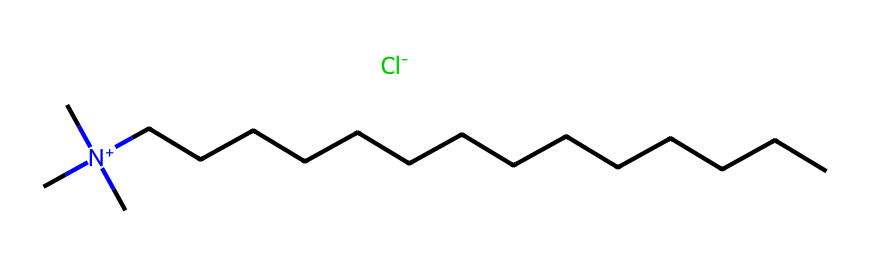What is the molecular cation in this compound? The compound has a positively charged nitrogen atom ([N+]), which is surrounded by three carbon groups (C) and a long hydrocarbon chain (CCCCCCCCCCCCCC). This indicates the presence of a quaternary ammonium ion.
Answer: quaternary ammonium ion How many carbon atoms are present in the long hydrocarbon chain? The long hydrocarbon chain is indicated by the series of carbon atoms labeled as CCCCCCCCCCCCCC, which has 14 carbon atoms.
Answer: 14 What type of chemical interaction is likely to be facilitated by this compound? Quaternary ammonium compounds typically act as surfactants and can facilitate interactions between water and hydrophobic substances, including membranes of algal cells, which can enhance their efficacy as algaecides.
Answer: surfactant Which ion is associated with this quaternary ammonium compound? The chemical structure includes a chloride ion ([Cl-]) associated with the quaternary ammonium cation, demonstrating its role in the overall stability of the compound in solution.
Answer: chloride ion What feature of this compound contributes to its effectiveness against harmful algal blooms? The long hydrophobic hydrocarbon chain (CCCCCCCCCCCCCC) allows the compound to integrate into algal membranes, disrupting their function and leading to cell death, which is critical for managing algal blooms.
Answer: hydrophobicity What charge does the nitrogen atom carry in this quaternary ammonium compound? The nitrogen atom is denoted as [N+], indicating that it carries a positive charge, which is a characteristic feature of quaternary ammonium compounds used in various applications, including algaecides.
Answer: positive charge 